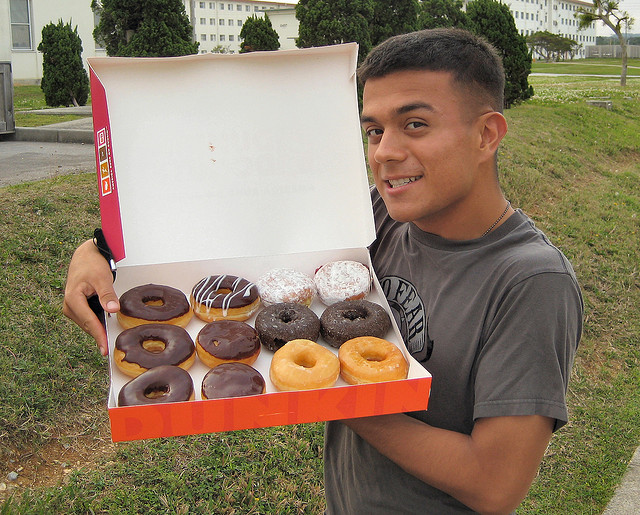Please transcribe the text information in this image. OFEAR 